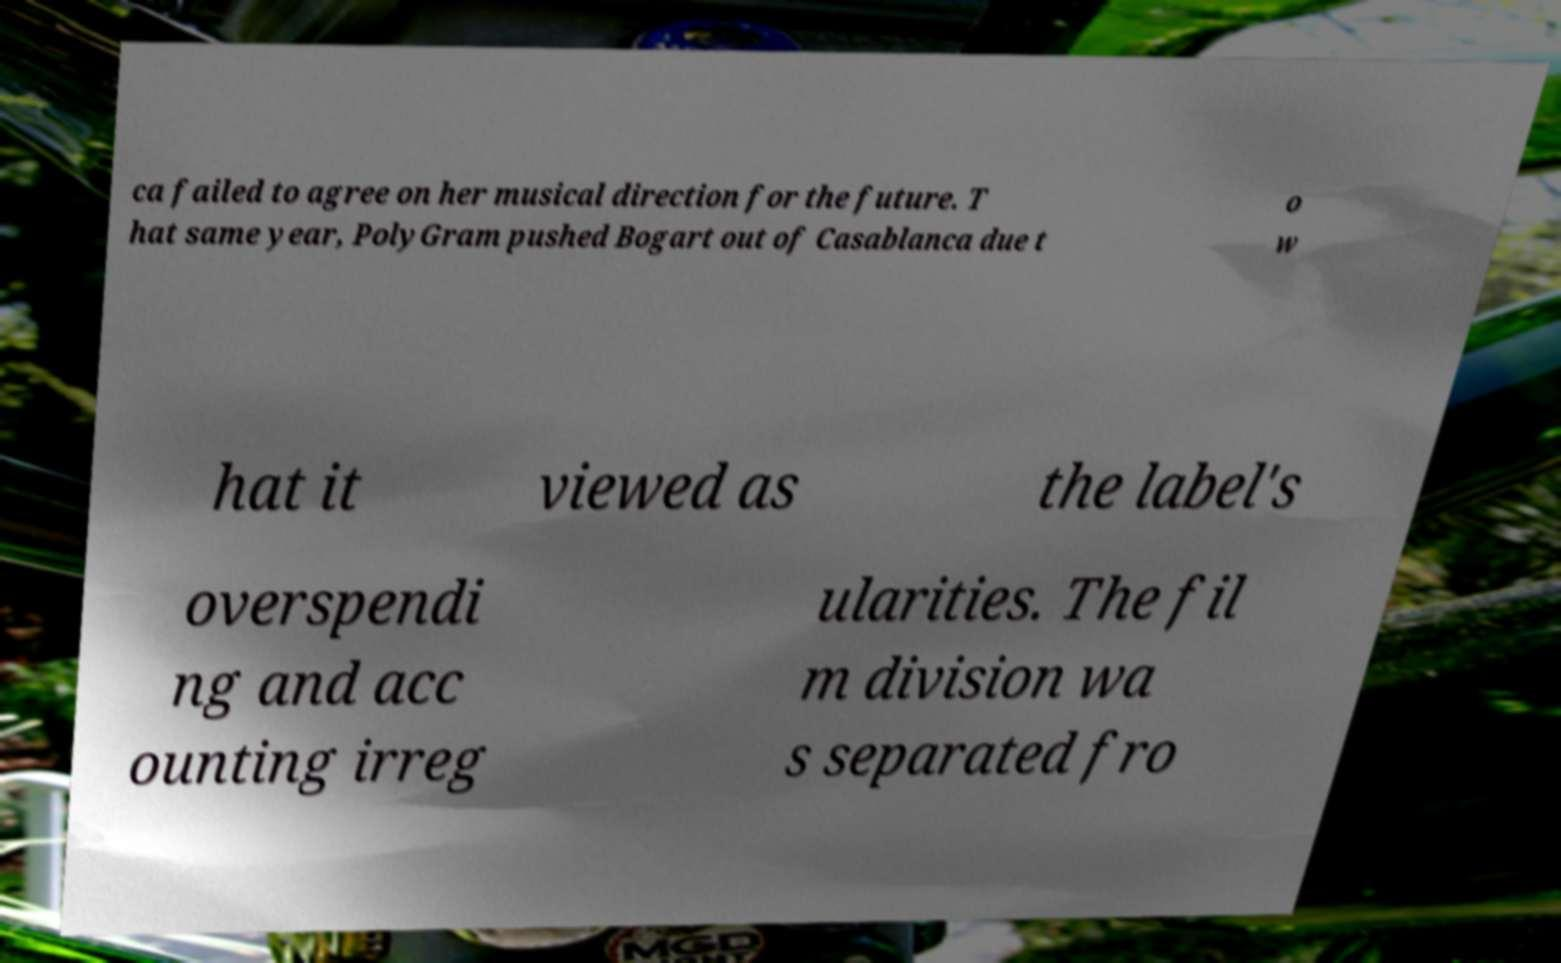Please read and relay the text visible in this image. What does it say? ca failed to agree on her musical direction for the future. T hat same year, PolyGram pushed Bogart out of Casablanca due t o w hat it viewed as the label's overspendi ng and acc ounting irreg ularities. The fil m division wa s separated fro 